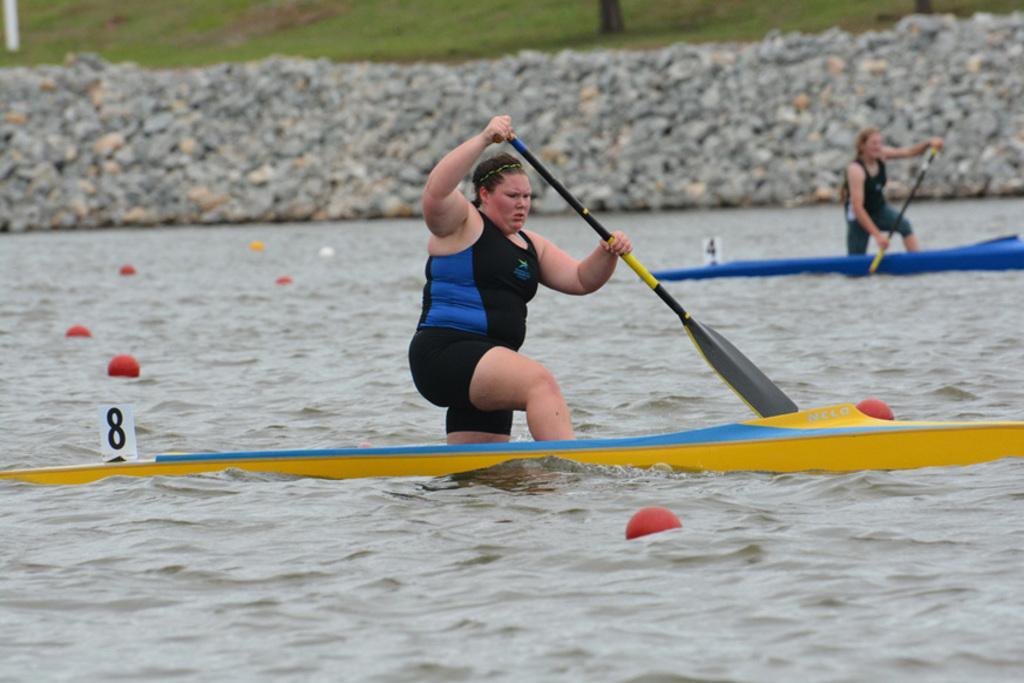In one or two sentences, can you explain what this image depicts? In this image I can see two women are paddling their boats are holding numbers. I can see some balls floating in the river water. I can see the rocks at the top of the image. I can see some green garden just above the rocks. 